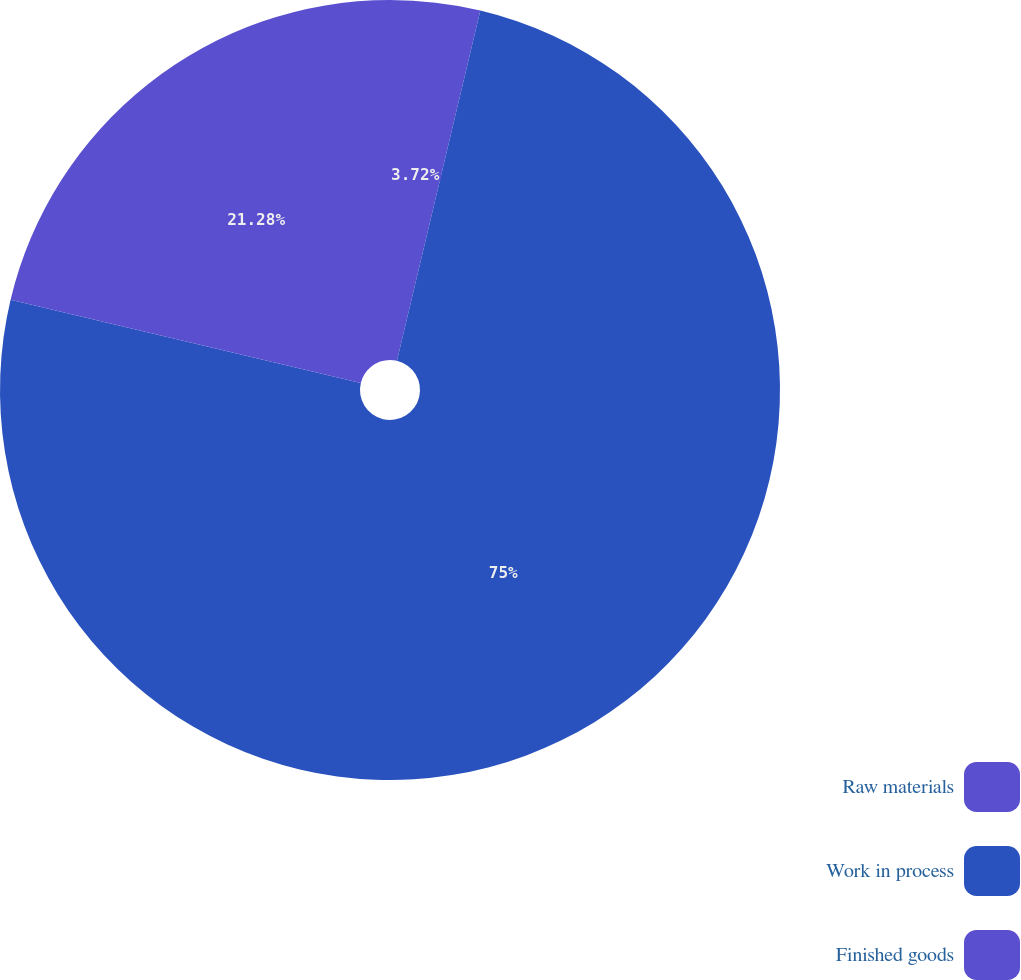Convert chart. <chart><loc_0><loc_0><loc_500><loc_500><pie_chart><fcel>Raw materials<fcel>Work in process<fcel>Finished goods<nl><fcel>3.72%<fcel>75.0%<fcel>21.28%<nl></chart> 